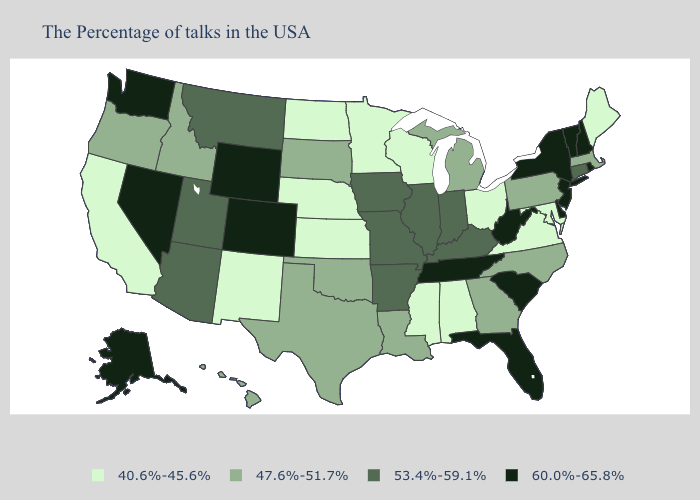What is the value of Louisiana?
Answer briefly. 47.6%-51.7%. Name the states that have a value in the range 47.6%-51.7%?
Keep it brief. Massachusetts, Pennsylvania, North Carolina, Georgia, Michigan, Louisiana, Oklahoma, Texas, South Dakota, Idaho, Oregon, Hawaii. What is the lowest value in the South?
Give a very brief answer. 40.6%-45.6%. Name the states that have a value in the range 47.6%-51.7%?
Keep it brief. Massachusetts, Pennsylvania, North Carolina, Georgia, Michigan, Louisiana, Oklahoma, Texas, South Dakota, Idaho, Oregon, Hawaii. Does the first symbol in the legend represent the smallest category?
Short answer required. Yes. What is the value of Arkansas?
Concise answer only. 53.4%-59.1%. What is the value of Virginia?
Short answer required. 40.6%-45.6%. Does Hawaii have the lowest value in the USA?
Write a very short answer. No. Does Maryland have a lower value than Nebraska?
Quick response, please. No. Does North Carolina have a lower value than Colorado?
Be succinct. Yes. Name the states that have a value in the range 40.6%-45.6%?
Short answer required. Maine, Maryland, Virginia, Ohio, Alabama, Wisconsin, Mississippi, Minnesota, Kansas, Nebraska, North Dakota, New Mexico, California. What is the lowest value in the West?
Be succinct. 40.6%-45.6%. What is the value of New Jersey?
Write a very short answer. 60.0%-65.8%. What is the lowest value in the Northeast?
Give a very brief answer. 40.6%-45.6%. What is the value of New Jersey?
Write a very short answer. 60.0%-65.8%. 